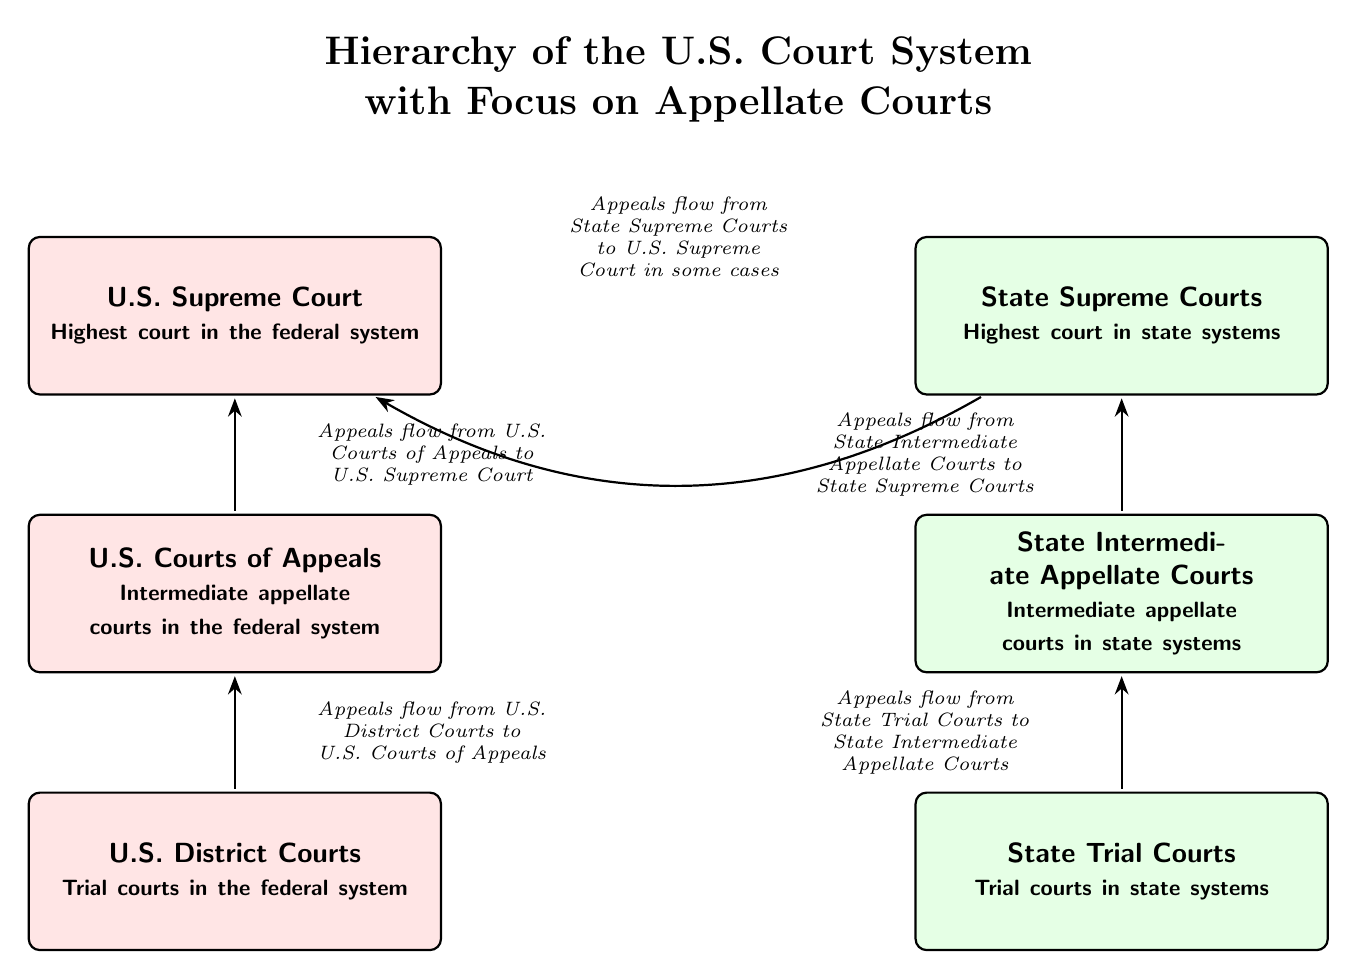What is the highest court in the federal system? According to the diagram, the U.S. Supreme Court is labeled as the highest court in the federal system, positioned at the top of the federal court structure.
Answer: U.S. Supreme Court How many levels are in the federal court system? The diagram shows three levels in the federal court system: U.S. District Courts, U.S. Courts of Appeals, and U.S. Supreme Court.
Answer: 3 What is the role of U.S. Courts of Appeals? The diagram indicates that U.S. Courts of Appeals serve as intermediate appellate courts in the federal system, positioned below the U.S. Supreme Court and above the U.S. District Courts.
Answer: Intermediate appellate courts From which courts do appeals flow to the U.S. Supreme Court in some cases? The arrows in the diagram illustrate that appeals flow from State Supreme Courts to the U.S. Supreme Court in some cases, demonstrating an intersection between state and federal court appeals.
Answer: State Supreme Courts What type of courts are at the bottom of the state court system? The diagram clearly shows that State Trial Courts are at the bottom of the state court system, as they are the foundational trial courts before cases can be appealed to higher courts.
Answer: State Trial Courts What indicates that appeals flow from State Intermediate Appellate Courts? The diagram features an arrow pointing from State Intermediate Appellate Courts to State Supreme Courts, which indicates the flow of appeals from the intermediate appellate courts to the highest state courts.
Answer: Arrow How does the federal court structure compare to the state court structure? Based on the diagram, both systems contain three levels, but the names of the courts differ, with federal courts being U.S. District Courts, U.S. Courts of Appeals, and U.S. Supreme Court, while state courts are State Trial Courts, State Intermediate Appellate Courts, and State Supreme Courts.
Answer: Different court names What type of relationship do U.S. District Courts have with U.S. Courts of Appeals? The diagram shows a direct flow of appeals from U.S. District Courts to U.S. Courts of Appeals, indicating a hierarchical relationship where decisions made at the district level can be reviewed by appellate courts.
Answer: Hierarchical relationship What does the diagram illustrate about the flow of appeals from state courts to the U.S. Supreme Court? The diagram represents the flow of appeals where State Supreme Courts can appeal cases to the U.S. Supreme Court, highlighting the relationship between state and federal appellate jurisdictions.
Answer: Flow of appeals How many total courts are displayed in the diagram? Counting all the court nodes in both the federal and state systems, there are a total of six courts displayed in the diagram: three federal courts and three state courts.
Answer: 6 